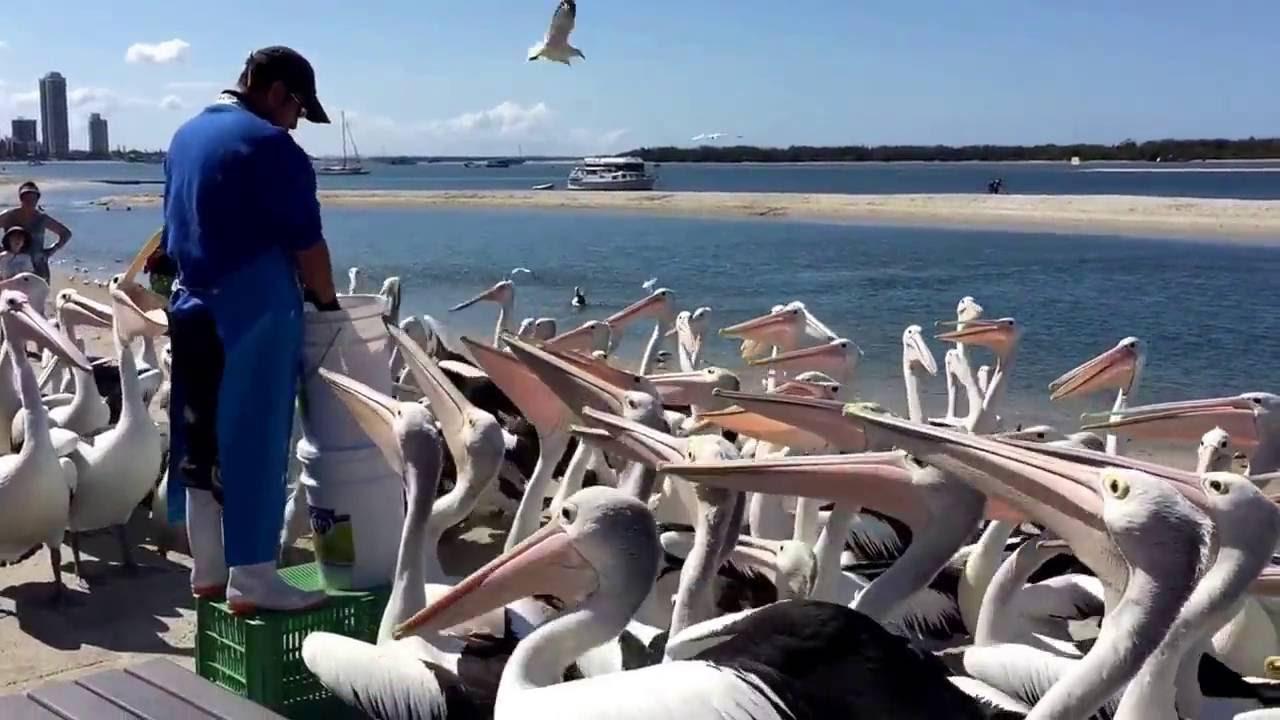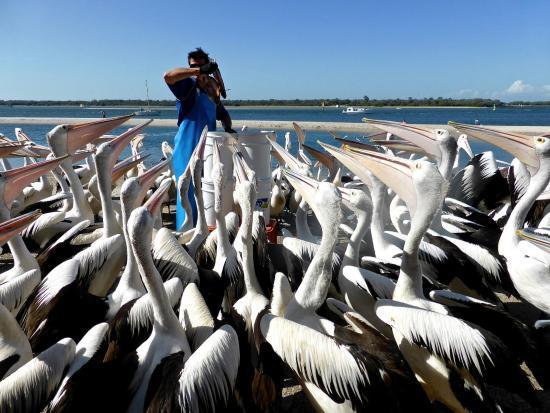The first image is the image on the left, the second image is the image on the right. Evaluate the accuracy of this statement regarding the images: "At least one pelican has its mouth open.". Is it true? Answer yes or no. No. 